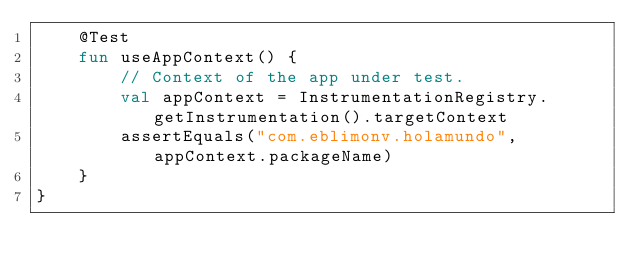<code> <loc_0><loc_0><loc_500><loc_500><_Kotlin_>    @Test
    fun useAppContext() {
        // Context of the app under test.
        val appContext = InstrumentationRegistry.getInstrumentation().targetContext
        assertEquals("com.eblimonv.holamundo", appContext.packageName)
    }
}</code> 